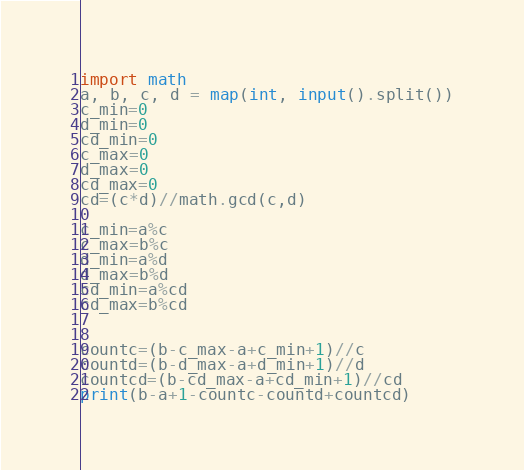Convert code to text. <code><loc_0><loc_0><loc_500><loc_500><_Python_>import math
a, b, c, d = map(int, input().split())
c_min=0
d_min=0
cd_min=0
c_max=0
d_max=0
cd_max=0
cd=(c*d)//math.gcd(c,d)

c_min=a%c
c_max=b%c
d_min=a%d
d_max=b%d
cd_min=a%cd
cd_max=b%cd


countc=(b-c_max-a+c_min+1)//c
countd=(b-d_max-a+d_min+1)//d
countcd=(b-cd_max-a+cd_min+1)//cd
print(b-a+1-countc-countd+countcd)


</code> 